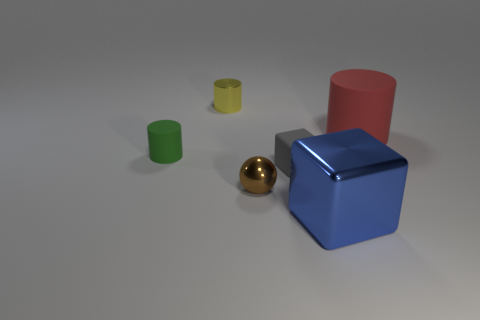Can you describe the shapes and colors of the objects in the image? Certainly! In the image, there are various geometric shapes that include two cylinders—one yellow and one red, two cubes—one blue and one green, and a golden sphere. 